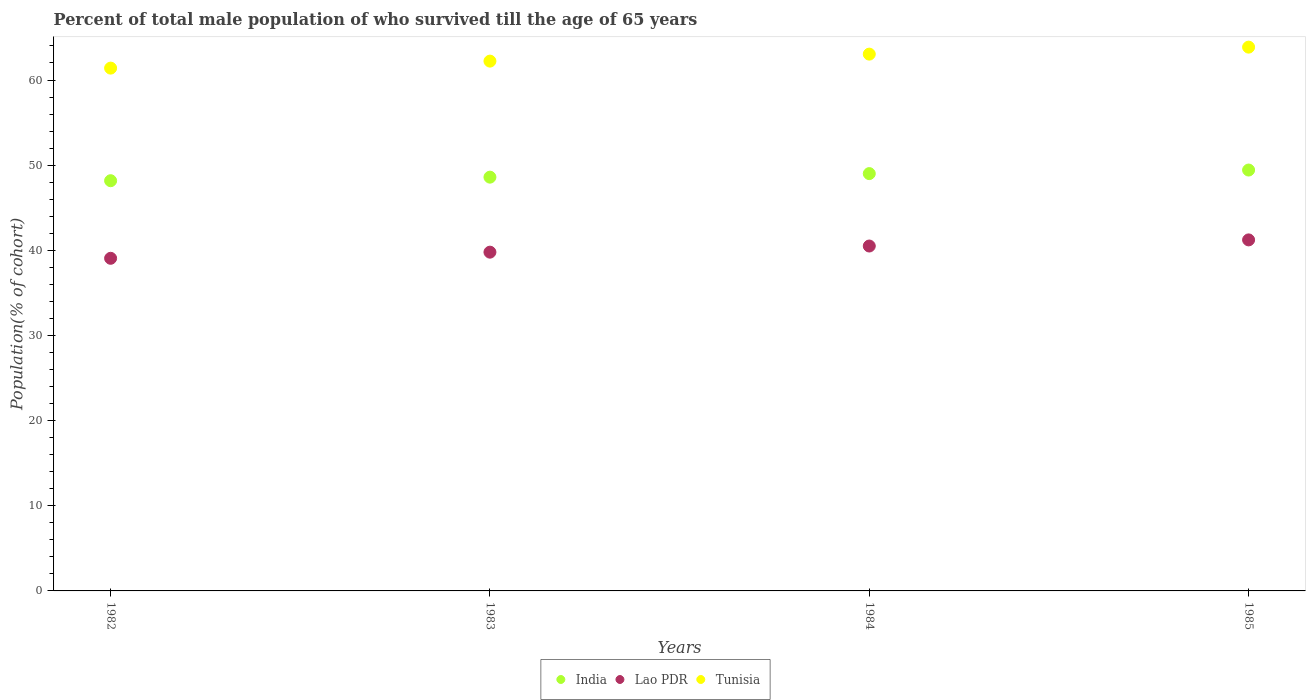How many different coloured dotlines are there?
Your answer should be compact. 3. Is the number of dotlines equal to the number of legend labels?
Provide a succinct answer. Yes. What is the percentage of total male population who survived till the age of 65 years in Tunisia in 1985?
Your response must be concise. 63.86. Across all years, what is the maximum percentage of total male population who survived till the age of 65 years in Tunisia?
Keep it short and to the point. 63.86. Across all years, what is the minimum percentage of total male population who survived till the age of 65 years in Lao PDR?
Provide a succinct answer. 39.06. In which year was the percentage of total male population who survived till the age of 65 years in Tunisia maximum?
Your answer should be very brief. 1985. In which year was the percentage of total male population who survived till the age of 65 years in Tunisia minimum?
Provide a short and direct response. 1982. What is the total percentage of total male population who survived till the age of 65 years in Tunisia in the graph?
Offer a terse response. 250.52. What is the difference between the percentage of total male population who survived till the age of 65 years in Tunisia in 1983 and that in 1984?
Your answer should be compact. -0.82. What is the difference between the percentage of total male population who survived till the age of 65 years in Tunisia in 1985 and the percentage of total male population who survived till the age of 65 years in Lao PDR in 1983?
Your answer should be very brief. 24.08. What is the average percentage of total male population who survived till the age of 65 years in Tunisia per year?
Ensure brevity in your answer.  62.63. In the year 1985, what is the difference between the percentage of total male population who survived till the age of 65 years in Lao PDR and percentage of total male population who survived till the age of 65 years in India?
Give a very brief answer. -8.2. In how many years, is the percentage of total male population who survived till the age of 65 years in India greater than 58 %?
Provide a succinct answer. 0. What is the ratio of the percentage of total male population who survived till the age of 65 years in Lao PDR in 1983 to that in 1985?
Your answer should be very brief. 0.97. What is the difference between the highest and the second highest percentage of total male population who survived till the age of 65 years in Lao PDR?
Give a very brief answer. 0.72. What is the difference between the highest and the lowest percentage of total male population who survived till the age of 65 years in Tunisia?
Your answer should be very brief. 2.46. In how many years, is the percentage of total male population who survived till the age of 65 years in Tunisia greater than the average percentage of total male population who survived till the age of 65 years in Tunisia taken over all years?
Ensure brevity in your answer.  2. Is it the case that in every year, the sum of the percentage of total male population who survived till the age of 65 years in Tunisia and percentage of total male population who survived till the age of 65 years in India  is greater than the percentage of total male population who survived till the age of 65 years in Lao PDR?
Offer a terse response. Yes. How many dotlines are there?
Keep it short and to the point. 3. How many years are there in the graph?
Offer a very short reply. 4. What is the difference between two consecutive major ticks on the Y-axis?
Provide a short and direct response. 10. Are the values on the major ticks of Y-axis written in scientific E-notation?
Your response must be concise. No. Does the graph contain any zero values?
Your answer should be very brief. No. Does the graph contain grids?
Your response must be concise. No. Where does the legend appear in the graph?
Your answer should be compact. Bottom center. How many legend labels are there?
Your response must be concise. 3. What is the title of the graph?
Your answer should be very brief. Percent of total male population of who survived till the age of 65 years. Does "India" appear as one of the legend labels in the graph?
Your answer should be compact. Yes. What is the label or title of the Y-axis?
Your response must be concise. Population(% of cohort). What is the Population(% of cohort) of India in 1982?
Offer a terse response. 48.17. What is the Population(% of cohort) in Lao PDR in 1982?
Make the answer very short. 39.06. What is the Population(% of cohort) in Tunisia in 1982?
Provide a succinct answer. 61.4. What is the Population(% of cohort) of India in 1983?
Your answer should be compact. 48.59. What is the Population(% of cohort) of Lao PDR in 1983?
Offer a very short reply. 39.78. What is the Population(% of cohort) of Tunisia in 1983?
Make the answer very short. 62.22. What is the Population(% of cohort) in India in 1984?
Make the answer very short. 49.01. What is the Population(% of cohort) of Lao PDR in 1984?
Make the answer very short. 40.5. What is the Population(% of cohort) in Tunisia in 1984?
Provide a succinct answer. 63.04. What is the Population(% of cohort) of India in 1985?
Offer a terse response. 49.43. What is the Population(% of cohort) of Lao PDR in 1985?
Ensure brevity in your answer.  41.22. What is the Population(% of cohort) in Tunisia in 1985?
Provide a short and direct response. 63.86. Across all years, what is the maximum Population(% of cohort) of India?
Offer a terse response. 49.43. Across all years, what is the maximum Population(% of cohort) in Lao PDR?
Offer a very short reply. 41.22. Across all years, what is the maximum Population(% of cohort) in Tunisia?
Offer a very short reply. 63.86. Across all years, what is the minimum Population(% of cohort) of India?
Your response must be concise. 48.17. Across all years, what is the minimum Population(% of cohort) in Lao PDR?
Your answer should be very brief. 39.06. Across all years, what is the minimum Population(% of cohort) of Tunisia?
Make the answer very short. 61.4. What is the total Population(% of cohort) of India in the graph?
Keep it short and to the point. 195.2. What is the total Population(% of cohort) in Lao PDR in the graph?
Provide a short and direct response. 160.57. What is the total Population(% of cohort) of Tunisia in the graph?
Offer a terse response. 250.52. What is the difference between the Population(% of cohort) in India in 1982 and that in 1983?
Provide a short and direct response. -0.42. What is the difference between the Population(% of cohort) of Lao PDR in 1982 and that in 1983?
Ensure brevity in your answer.  -0.72. What is the difference between the Population(% of cohort) of Tunisia in 1982 and that in 1983?
Offer a very short reply. -0.82. What is the difference between the Population(% of cohort) in India in 1982 and that in 1984?
Your answer should be compact. -0.84. What is the difference between the Population(% of cohort) in Lao PDR in 1982 and that in 1984?
Offer a terse response. -1.44. What is the difference between the Population(% of cohort) of Tunisia in 1982 and that in 1984?
Ensure brevity in your answer.  -1.64. What is the difference between the Population(% of cohort) of India in 1982 and that in 1985?
Keep it short and to the point. -1.25. What is the difference between the Population(% of cohort) in Lao PDR in 1982 and that in 1985?
Your response must be concise. -2.16. What is the difference between the Population(% of cohort) of Tunisia in 1982 and that in 1985?
Offer a very short reply. -2.46. What is the difference between the Population(% of cohort) of India in 1983 and that in 1984?
Your response must be concise. -0.42. What is the difference between the Population(% of cohort) of Lao PDR in 1983 and that in 1984?
Your answer should be compact. -0.72. What is the difference between the Population(% of cohort) in Tunisia in 1983 and that in 1984?
Ensure brevity in your answer.  -0.82. What is the difference between the Population(% of cohort) of India in 1983 and that in 1985?
Offer a very short reply. -0.84. What is the difference between the Population(% of cohort) in Lao PDR in 1983 and that in 1985?
Give a very brief answer. -1.44. What is the difference between the Population(% of cohort) of Tunisia in 1983 and that in 1985?
Ensure brevity in your answer.  -1.64. What is the difference between the Population(% of cohort) in India in 1984 and that in 1985?
Offer a very short reply. -0.42. What is the difference between the Population(% of cohort) of Lao PDR in 1984 and that in 1985?
Provide a short and direct response. -0.72. What is the difference between the Population(% of cohort) of Tunisia in 1984 and that in 1985?
Ensure brevity in your answer.  -0.82. What is the difference between the Population(% of cohort) in India in 1982 and the Population(% of cohort) in Lao PDR in 1983?
Your response must be concise. 8.39. What is the difference between the Population(% of cohort) in India in 1982 and the Population(% of cohort) in Tunisia in 1983?
Your response must be concise. -14.04. What is the difference between the Population(% of cohort) in Lao PDR in 1982 and the Population(% of cohort) in Tunisia in 1983?
Provide a succinct answer. -23.16. What is the difference between the Population(% of cohort) of India in 1982 and the Population(% of cohort) of Lao PDR in 1984?
Give a very brief answer. 7.67. What is the difference between the Population(% of cohort) in India in 1982 and the Population(% of cohort) in Tunisia in 1984?
Make the answer very short. -14.87. What is the difference between the Population(% of cohort) of Lao PDR in 1982 and the Population(% of cohort) of Tunisia in 1984?
Your answer should be compact. -23.98. What is the difference between the Population(% of cohort) in India in 1982 and the Population(% of cohort) in Lao PDR in 1985?
Make the answer very short. 6.95. What is the difference between the Population(% of cohort) of India in 1982 and the Population(% of cohort) of Tunisia in 1985?
Offer a terse response. -15.69. What is the difference between the Population(% of cohort) of Lao PDR in 1982 and the Population(% of cohort) of Tunisia in 1985?
Your response must be concise. -24.8. What is the difference between the Population(% of cohort) in India in 1983 and the Population(% of cohort) in Lao PDR in 1984?
Keep it short and to the point. 8.09. What is the difference between the Population(% of cohort) of India in 1983 and the Population(% of cohort) of Tunisia in 1984?
Your response must be concise. -14.45. What is the difference between the Population(% of cohort) in Lao PDR in 1983 and the Population(% of cohort) in Tunisia in 1984?
Keep it short and to the point. -23.26. What is the difference between the Population(% of cohort) of India in 1983 and the Population(% of cohort) of Lao PDR in 1985?
Keep it short and to the point. 7.37. What is the difference between the Population(% of cohort) in India in 1983 and the Population(% of cohort) in Tunisia in 1985?
Your response must be concise. -15.27. What is the difference between the Population(% of cohort) in Lao PDR in 1983 and the Population(% of cohort) in Tunisia in 1985?
Ensure brevity in your answer.  -24.08. What is the difference between the Population(% of cohort) of India in 1984 and the Population(% of cohort) of Lao PDR in 1985?
Provide a succinct answer. 7.79. What is the difference between the Population(% of cohort) in India in 1984 and the Population(% of cohort) in Tunisia in 1985?
Provide a short and direct response. -14.85. What is the difference between the Population(% of cohort) in Lao PDR in 1984 and the Population(% of cohort) in Tunisia in 1985?
Ensure brevity in your answer.  -23.36. What is the average Population(% of cohort) in India per year?
Your response must be concise. 48.8. What is the average Population(% of cohort) of Lao PDR per year?
Provide a succinct answer. 40.14. What is the average Population(% of cohort) of Tunisia per year?
Provide a succinct answer. 62.63. In the year 1982, what is the difference between the Population(% of cohort) of India and Population(% of cohort) of Lao PDR?
Make the answer very short. 9.11. In the year 1982, what is the difference between the Population(% of cohort) in India and Population(% of cohort) in Tunisia?
Provide a succinct answer. -13.22. In the year 1982, what is the difference between the Population(% of cohort) in Lao PDR and Population(% of cohort) in Tunisia?
Your answer should be very brief. -22.33. In the year 1983, what is the difference between the Population(% of cohort) in India and Population(% of cohort) in Lao PDR?
Offer a terse response. 8.81. In the year 1983, what is the difference between the Population(% of cohort) in India and Population(% of cohort) in Tunisia?
Provide a short and direct response. -13.63. In the year 1983, what is the difference between the Population(% of cohort) in Lao PDR and Population(% of cohort) in Tunisia?
Make the answer very short. -22.44. In the year 1984, what is the difference between the Population(% of cohort) of India and Population(% of cohort) of Lao PDR?
Keep it short and to the point. 8.51. In the year 1984, what is the difference between the Population(% of cohort) in India and Population(% of cohort) in Tunisia?
Your answer should be very brief. -14.03. In the year 1984, what is the difference between the Population(% of cohort) of Lao PDR and Population(% of cohort) of Tunisia?
Your response must be concise. -22.54. In the year 1985, what is the difference between the Population(% of cohort) in India and Population(% of cohort) in Lao PDR?
Provide a short and direct response. 8.2. In the year 1985, what is the difference between the Population(% of cohort) in India and Population(% of cohort) in Tunisia?
Your answer should be very brief. -14.43. In the year 1985, what is the difference between the Population(% of cohort) of Lao PDR and Population(% of cohort) of Tunisia?
Your answer should be very brief. -22.64. What is the ratio of the Population(% of cohort) of India in 1982 to that in 1983?
Offer a terse response. 0.99. What is the ratio of the Population(% of cohort) of Lao PDR in 1982 to that in 1983?
Your answer should be very brief. 0.98. What is the ratio of the Population(% of cohort) in India in 1982 to that in 1984?
Your response must be concise. 0.98. What is the ratio of the Population(% of cohort) of Lao PDR in 1982 to that in 1984?
Your answer should be compact. 0.96. What is the ratio of the Population(% of cohort) of Tunisia in 1982 to that in 1984?
Make the answer very short. 0.97. What is the ratio of the Population(% of cohort) of India in 1982 to that in 1985?
Give a very brief answer. 0.97. What is the ratio of the Population(% of cohort) of Lao PDR in 1982 to that in 1985?
Offer a very short reply. 0.95. What is the ratio of the Population(% of cohort) of Tunisia in 1982 to that in 1985?
Your answer should be compact. 0.96. What is the ratio of the Population(% of cohort) of India in 1983 to that in 1984?
Keep it short and to the point. 0.99. What is the ratio of the Population(% of cohort) in Lao PDR in 1983 to that in 1984?
Your answer should be very brief. 0.98. What is the ratio of the Population(% of cohort) of Tunisia in 1983 to that in 1984?
Your answer should be very brief. 0.99. What is the ratio of the Population(% of cohort) in India in 1983 to that in 1985?
Make the answer very short. 0.98. What is the ratio of the Population(% of cohort) of Lao PDR in 1983 to that in 1985?
Offer a very short reply. 0.96. What is the ratio of the Population(% of cohort) of Tunisia in 1983 to that in 1985?
Your response must be concise. 0.97. What is the ratio of the Population(% of cohort) of India in 1984 to that in 1985?
Your answer should be compact. 0.99. What is the ratio of the Population(% of cohort) of Lao PDR in 1984 to that in 1985?
Give a very brief answer. 0.98. What is the ratio of the Population(% of cohort) of Tunisia in 1984 to that in 1985?
Your answer should be compact. 0.99. What is the difference between the highest and the second highest Population(% of cohort) in India?
Offer a terse response. 0.42. What is the difference between the highest and the second highest Population(% of cohort) in Lao PDR?
Offer a terse response. 0.72. What is the difference between the highest and the second highest Population(% of cohort) of Tunisia?
Keep it short and to the point. 0.82. What is the difference between the highest and the lowest Population(% of cohort) in India?
Offer a terse response. 1.25. What is the difference between the highest and the lowest Population(% of cohort) of Lao PDR?
Give a very brief answer. 2.16. What is the difference between the highest and the lowest Population(% of cohort) in Tunisia?
Offer a very short reply. 2.46. 